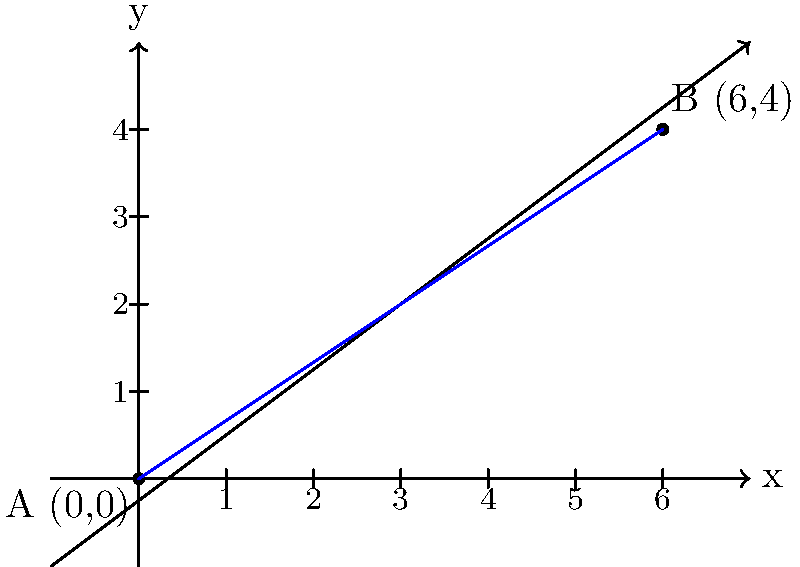In Asyut, two important religious locations are represented on a coordinate plane. The first location, point A, is at the origin (0,0), while the second location, point B, is at coordinates (6,4). Calculate the slope of the line connecting these two significant sites. To find the slope of the line connecting two points, we use the slope formula:

$$ m = \frac{y_2 - y_1}{x_2 - x_1} $$

Where $(x_1, y_1)$ represents the coordinates of the first point and $(x_2, y_2)$ represents the coordinates of the second point.

Given:
Point A: $(x_1, y_1) = (0, 0)$
Point B: $(x_2, y_2) = (6, 4)$

Let's substitute these values into the slope formula:

$$ m = \frac{4 - 0}{6 - 0} = \frac{4}{6} $$

Simplify the fraction:

$$ m = \frac{2}{3} $$

Therefore, the slope of the line connecting the two religious locations is $\frac{2}{3}$.
Answer: $\frac{2}{3}$ 